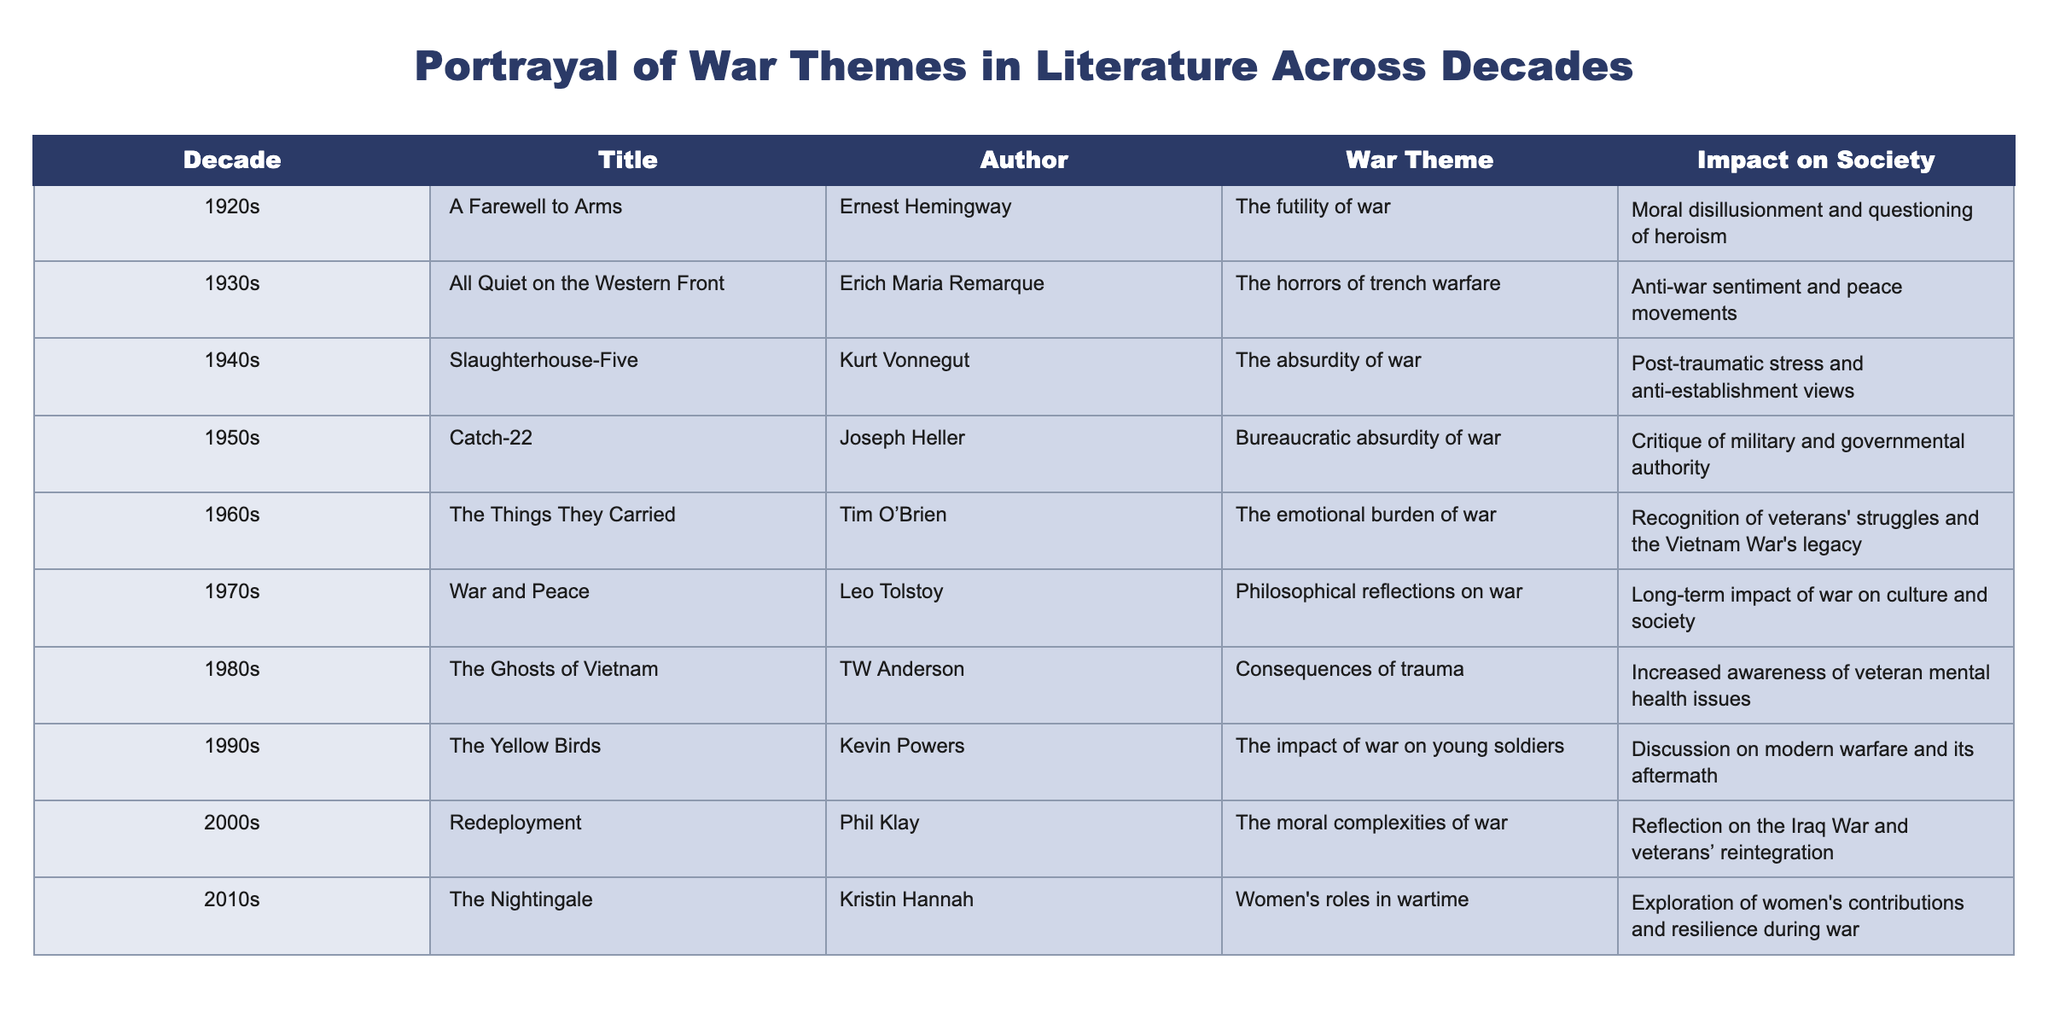What is the title of the novel from the 1960s that addresses the emotional burden of war? The table indicates that "The Things They Carried" by Tim O'Brien addresses the emotional burden of war in the 1960s.
Answer: The Things They Carried In which decade was "All Quiet on the Western Front" published? The table shows that "All Quiet on the Western Front" by Erich Maria Remarque was published in the 1930s.
Answer: 1930s How many novels in the table discuss the consequences of trauma? From the table, I can see "The Ghosts of Vietnam" and "Redeployment" both address the consequences of trauma, giving a total of 2 novels.
Answer: 2 What is the impact on society reflected in "Catch-22"? The table states that "Catch-22" by Joseph Heller critiques military and governmental authority, which is its impact on society.
Answer: Critique of military and governmental authority Is it true that all novels from the 2000s focus on the Iraq War? The table shows that "Redeployment," the novel from the 2000s, does reflect on the Iraq War; however, this does not indicate that all novels from the 2000s focus on the Iraq War. Thus, the statement is false.
Answer: False Which author wrote about the philosophical reflections on war? The table reveals that Leo Tolstoy wrote "War and Peace," which focuses on philosophical reflections on war.
Answer: Leo Tolstoy What is the average decade of publication for the novels listed? The decades represented are 1920s, 1930s, 1940s, 1950s, 1960s, 1970s, 1980s, 1990s, 2000s, and 2010s, which corresponds to the numbers 1920, 1930, 1940, 1950, 1960, 1970, 1980, 1990, 2000, 2010 (10 decades). Summing these decades gives a total of 19,200. Dividing this by 10 provides the average decade of 1,920, or the 1970s.
Answer: 1970s Which war-themed novel from the 2010s explores women's roles in wartime? According to the table, "The Nightingale" by Kristin Hannah, published in the 2010s, explores women's roles in wartime.
Answer: The Nightingale What are the themes of the novels published in the 1980s compared to those in the 1940s? For the 1980s, "The Ghosts of Vietnam" focuses on the consequences of trauma, whereas the 1940s novel "Slaughterhouse-Five" deals with the absurdity of war. This comparison shows a shift from an individual impact of trauma to a broader existential reflection on the absurdity of war.
Answer: Consequences of trauma vs. absurdity of war 